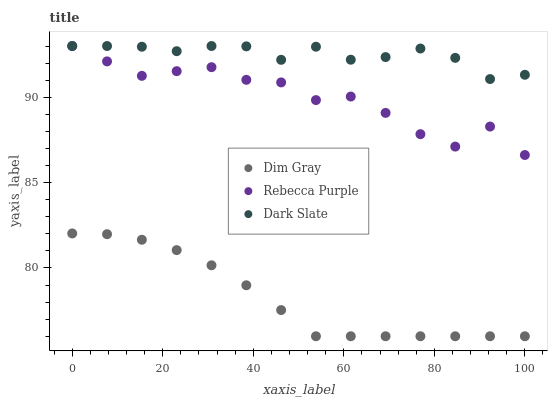Does Dim Gray have the minimum area under the curve?
Answer yes or no. Yes. Does Dark Slate have the maximum area under the curve?
Answer yes or no. Yes. Does Rebecca Purple have the minimum area under the curve?
Answer yes or no. No. Does Rebecca Purple have the maximum area under the curve?
Answer yes or no. No. Is Dim Gray the smoothest?
Answer yes or no. Yes. Is Rebecca Purple the roughest?
Answer yes or no. Yes. Is Rebecca Purple the smoothest?
Answer yes or no. No. Is Dim Gray the roughest?
Answer yes or no. No. Does Dim Gray have the lowest value?
Answer yes or no. Yes. Does Rebecca Purple have the lowest value?
Answer yes or no. No. Does Rebecca Purple have the highest value?
Answer yes or no. Yes. Does Dim Gray have the highest value?
Answer yes or no. No. Is Dim Gray less than Dark Slate?
Answer yes or no. Yes. Is Dark Slate greater than Dim Gray?
Answer yes or no. Yes. Does Rebecca Purple intersect Dark Slate?
Answer yes or no. Yes. Is Rebecca Purple less than Dark Slate?
Answer yes or no. No. Is Rebecca Purple greater than Dark Slate?
Answer yes or no. No. Does Dim Gray intersect Dark Slate?
Answer yes or no. No. 